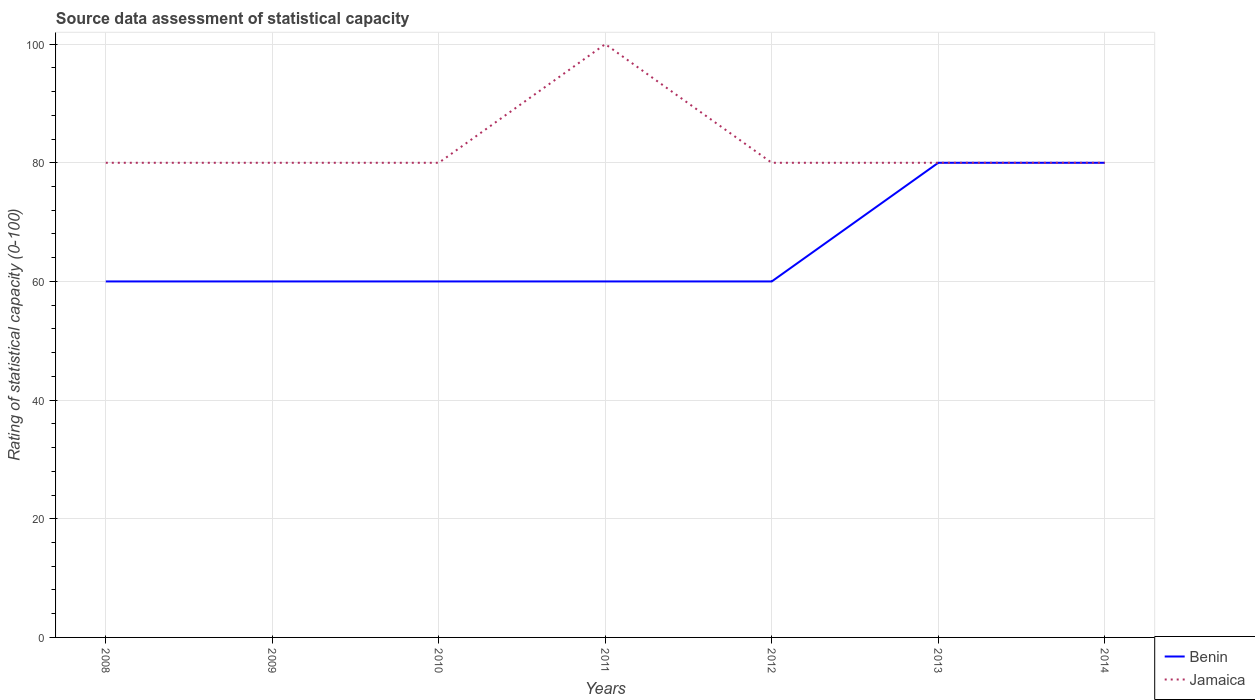How many different coloured lines are there?
Offer a very short reply. 2. Does the line corresponding to Jamaica intersect with the line corresponding to Benin?
Your response must be concise. Yes. Is the number of lines equal to the number of legend labels?
Provide a short and direct response. Yes. Across all years, what is the maximum rating of statistical capacity in Jamaica?
Keep it short and to the point. 80. What is the difference between the highest and the second highest rating of statistical capacity in Jamaica?
Provide a short and direct response. 20. Is the rating of statistical capacity in Benin strictly greater than the rating of statistical capacity in Jamaica over the years?
Provide a short and direct response. No. How many lines are there?
Your response must be concise. 2. How many years are there in the graph?
Provide a succinct answer. 7. Are the values on the major ticks of Y-axis written in scientific E-notation?
Make the answer very short. No. Does the graph contain any zero values?
Keep it short and to the point. No. Does the graph contain grids?
Offer a very short reply. Yes. How are the legend labels stacked?
Give a very brief answer. Vertical. What is the title of the graph?
Provide a short and direct response. Source data assessment of statistical capacity. What is the label or title of the Y-axis?
Offer a terse response. Rating of statistical capacity (0-100). What is the Rating of statistical capacity (0-100) in Benin in 2008?
Your response must be concise. 60. What is the Rating of statistical capacity (0-100) of Jamaica in 2008?
Ensure brevity in your answer.  80. What is the Rating of statistical capacity (0-100) in Benin in 2009?
Provide a succinct answer. 60. What is the Rating of statistical capacity (0-100) of Benin in 2010?
Give a very brief answer. 60. What is the Rating of statistical capacity (0-100) of Benin in 2011?
Ensure brevity in your answer.  60. What is the Rating of statistical capacity (0-100) in Jamaica in 2012?
Ensure brevity in your answer.  80. What is the Rating of statistical capacity (0-100) in Benin in 2013?
Offer a terse response. 80. What is the Rating of statistical capacity (0-100) of Benin in 2014?
Your answer should be compact. 80. What is the Rating of statistical capacity (0-100) in Jamaica in 2014?
Make the answer very short. 80. Across all years, what is the maximum Rating of statistical capacity (0-100) of Benin?
Your answer should be compact. 80. Across all years, what is the maximum Rating of statistical capacity (0-100) in Jamaica?
Keep it short and to the point. 100. Across all years, what is the minimum Rating of statistical capacity (0-100) of Jamaica?
Give a very brief answer. 80. What is the total Rating of statistical capacity (0-100) of Benin in the graph?
Make the answer very short. 460. What is the total Rating of statistical capacity (0-100) in Jamaica in the graph?
Offer a very short reply. 580. What is the difference between the Rating of statistical capacity (0-100) in Jamaica in 2008 and that in 2009?
Your answer should be compact. 0. What is the difference between the Rating of statistical capacity (0-100) of Benin in 2008 and that in 2012?
Offer a terse response. 0. What is the difference between the Rating of statistical capacity (0-100) in Jamaica in 2008 and that in 2012?
Your response must be concise. 0. What is the difference between the Rating of statistical capacity (0-100) of Benin in 2008 and that in 2013?
Ensure brevity in your answer.  -20. What is the difference between the Rating of statistical capacity (0-100) in Jamaica in 2008 and that in 2013?
Offer a very short reply. 0. What is the difference between the Rating of statistical capacity (0-100) of Benin in 2009 and that in 2010?
Make the answer very short. 0. What is the difference between the Rating of statistical capacity (0-100) of Jamaica in 2009 and that in 2010?
Offer a terse response. 0. What is the difference between the Rating of statistical capacity (0-100) in Benin in 2009 and that in 2011?
Your answer should be very brief. 0. What is the difference between the Rating of statistical capacity (0-100) of Jamaica in 2009 and that in 2011?
Provide a short and direct response. -20. What is the difference between the Rating of statistical capacity (0-100) in Benin in 2010 and that in 2012?
Your response must be concise. 0. What is the difference between the Rating of statistical capacity (0-100) of Benin in 2010 and that in 2014?
Your answer should be very brief. -20. What is the difference between the Rating of statistical capacity (0-100) in Jamaica in 2010 and that in 2014?
Ensure brevity in your answer.  0. What is the difference between the Rating of statistical capacity (0-100) in Benin in 2011 and that in 2012?
Give a very brief answer. 0. What is the difference between the Rating of statistical capacity (0-100) in Jamaica in 2011 and that in 2012?
Offer a very short reply. 20. What is the difference between the Rating of statistical capacity (0-100) of Benin in 2011 and that in 2014?
Offer a terse response. -20. What is the difference between the Rating of statistical capacity (0-100) in Jamaica in 2011 and that in 2014?
Your response must be concise. 20. What is the difference between the Rating of statistical capacity (0-100) in Benin in 2012 and that in 2013?
Make the answer very short. -20. What is the difference between the Rating of statistical capacity (0-100) in Jamaica in 2012 and that in 2013?
Keep it short and to the point. 0. What is the difference between the Rating of statistical capacity (0-100) in Jamaica in 2013 and that in 2014?
Give a very brief answer. 0. What is the difference between the Rating of statistical capacity (0-100) in Benin in 2008 and the Rating of statistical capacity (0-100) in Jamaica in 2009?
Make the answer very short. -20. What is the difference between the Rating of statistical capacity (0-100) of Benin in 2008 and the Rating of statistical capacity (0-100) of Jamaica in 2012?
Provide a succinct answer. -20. What is the difference between the Rating of statistical capacity (0-100) of Benin in 2009 and the Rating of statistical capacity (0-100) of Jamaica in 2011?
Provide a short and direct response. -40. What is the difference between the Rating of statistical capacity (0-100) of Benin in 2009 and the Rating of statistical capacity (0-100) of Jamaica in 2013?
Your answer should be compact. -20. What is the difference between the Rating of statistical capacity (0-100) in Benin in 2009 and the Rating of statistical capacity (0-100) in Jamaica in 2014?
Offer a terse response. -20. What is the difference between the Rating of statistical capacity (0-100) of Benin in 2010 and the Rating of statistical capacity (0-100) of Jamaica in 2013?
Ensure brevity in your answer.  -20. What is the difference between the Rating of statistical capacity (0-100) in Benin in 2010 and the Rating of statistical capacity (0-100) in Jamaica in 2014?
Keep it short and to the point. -20. What is the difference between the Rating of statistical capacity (0-100) in Benin in 2011 and the Rating of statistical capacity (0-100) in Jamaica in 2014?
Offer a terse response. -20. What is the difference between the Rating of statistical capacity (0-100) in Benin in 2012 and the Rating of statistical capacity (0-100) in Jamaica in 2013?
Your answer should be compact. -20. What is the average Rating of statistical capacity (0-100) of Benin per year?
Your answer should be compact. 65.71. What is the average Rating of statistical capacity (0-100) of Jamaica per year?
Your response must be concise. 82.86. In the year 2008, what is the difference between the Rating of statistical capacity (0-100) of Benin and Rating of statistical capacity (0-100) of Jamaica?
Keep it short and to the point. -20. In the year 2009, what is the difference between the Rating of statistical capacity (0-100) of Benin and Rating of statistical capacity (0-100) of Jamaica?
Your answer should be very brief. -20. In the year 2010, what is the difference between the Rating of statistical capacity (0-100) of Benin and Rating of statistical capacity (0-100) of Jamaica?
Your response must be concise. -20. In the year 2011, what is the difference between the Rating of statistical capacity (0-100) of Benin and Rating of statistical capacity (0-100) of Jamaica?
Offer a terse response. -40. In the year 2012, what is the difference between the Rating of statistical capacity (0-100) of Benin and Rating of statistical capacity (0-100) of Jamaica?
Your answer should be very brief. -20. What is the ratio of the Rating of statistical capacity (0-100) of Jamaica in 2008 to that in 2010?
Make the answer very short. 1. What is the ratio of the Rating of statistical capacity (0-100) of Jamaica in 2008 to that in 2013?
Provide a short and direct response. 1. What is the ratio of the Rating of statistical capacity (0-100) of Jamaica in 2008 to that in 2014?
Your answer should be very brief. 1. What is the ratio of the Rating of statistical capacity (0-100) of Jamaica in 2009 to that in 2011?
Offer a very short reply. 0.8. What is the ratio of the Rating of statistical capacity (0-100) in Jamaica in 2009 to that in 2012?
Provide a succinct answer. 1. What is the ratio of the Rating of statistical capacity (0-100) in Jamaica in 2009 to that in 2013?
Your answer should be very brief. 1. What is the ratio of the Rating of statistical capacity (0-100) in Benin in 2009 to that in 2014?
Offer a terse response. 0.75. What is the ratio of the Rating of statistical capacity (0-100) of Benin in 2010 to that in 2014?
Ensure brevity in your answer.  0.75. What is the ratio of the Rating of statistical capacity (0-100) of Jamaica in 2010 to that in 2014?
Offer a very short reply. 1. What is the ratio of the Rating of statistical capacity (0-100) of Jamaica in 2011 to that in 2012?
Offer a very short reply. 1.25. What is the ratio of the Rating of statistical capacity (0-100) of Jamaica in 2011 to that in 2013?
Offer a terse response. 1.25. What is the ratio of the Rating of statistical capacity (0-100) in Benin in 2011 to that in 2014?
Offer a very short reply. 0.75. What is the ratio of the Rating of statistical capacity (0-100) of Benin in 2012 to that in 2013?
Keep it short and to the point. 0.75. What is the ratio of the Rating of statistical capacity (0-100) of Jamaica in 2012 to that in 2014?
Offer a terse response. 1. What is the ratio of the Rating of statistical capacity (0-100) of Benin in 2013 to that in 2014?
Your answer should be very brief. 1. What is the ratio of the Rating of statistical capacity (0-100) in Jamaica in 2013 to that in 2014?
Offer a terse response. 1. What is the difference between the highest and the second highest Rating of statistical capacity (0-100) in Benin?
Keep it short and to the point. 0. What is the difference between the highest and the second highest Rating of statistical capacity (0-100) in Jamaica?
Provide a short and direct response. 20. 